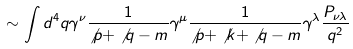Convert formula to latex. <formula><loc_0><loc_0><loc_500><loc_500>\sim \int d ^ { 4 } q \gamma ^ { \nu } \frac { 1 } { \not p + \not q - m } \gamma ^ { \mu } \frac { 1 } { \not p + \not k + \not q - m } \gamma ^ { \lambda } \frac { P _ { \nu \lambda } } { q ^ { 2 } }</formula> 